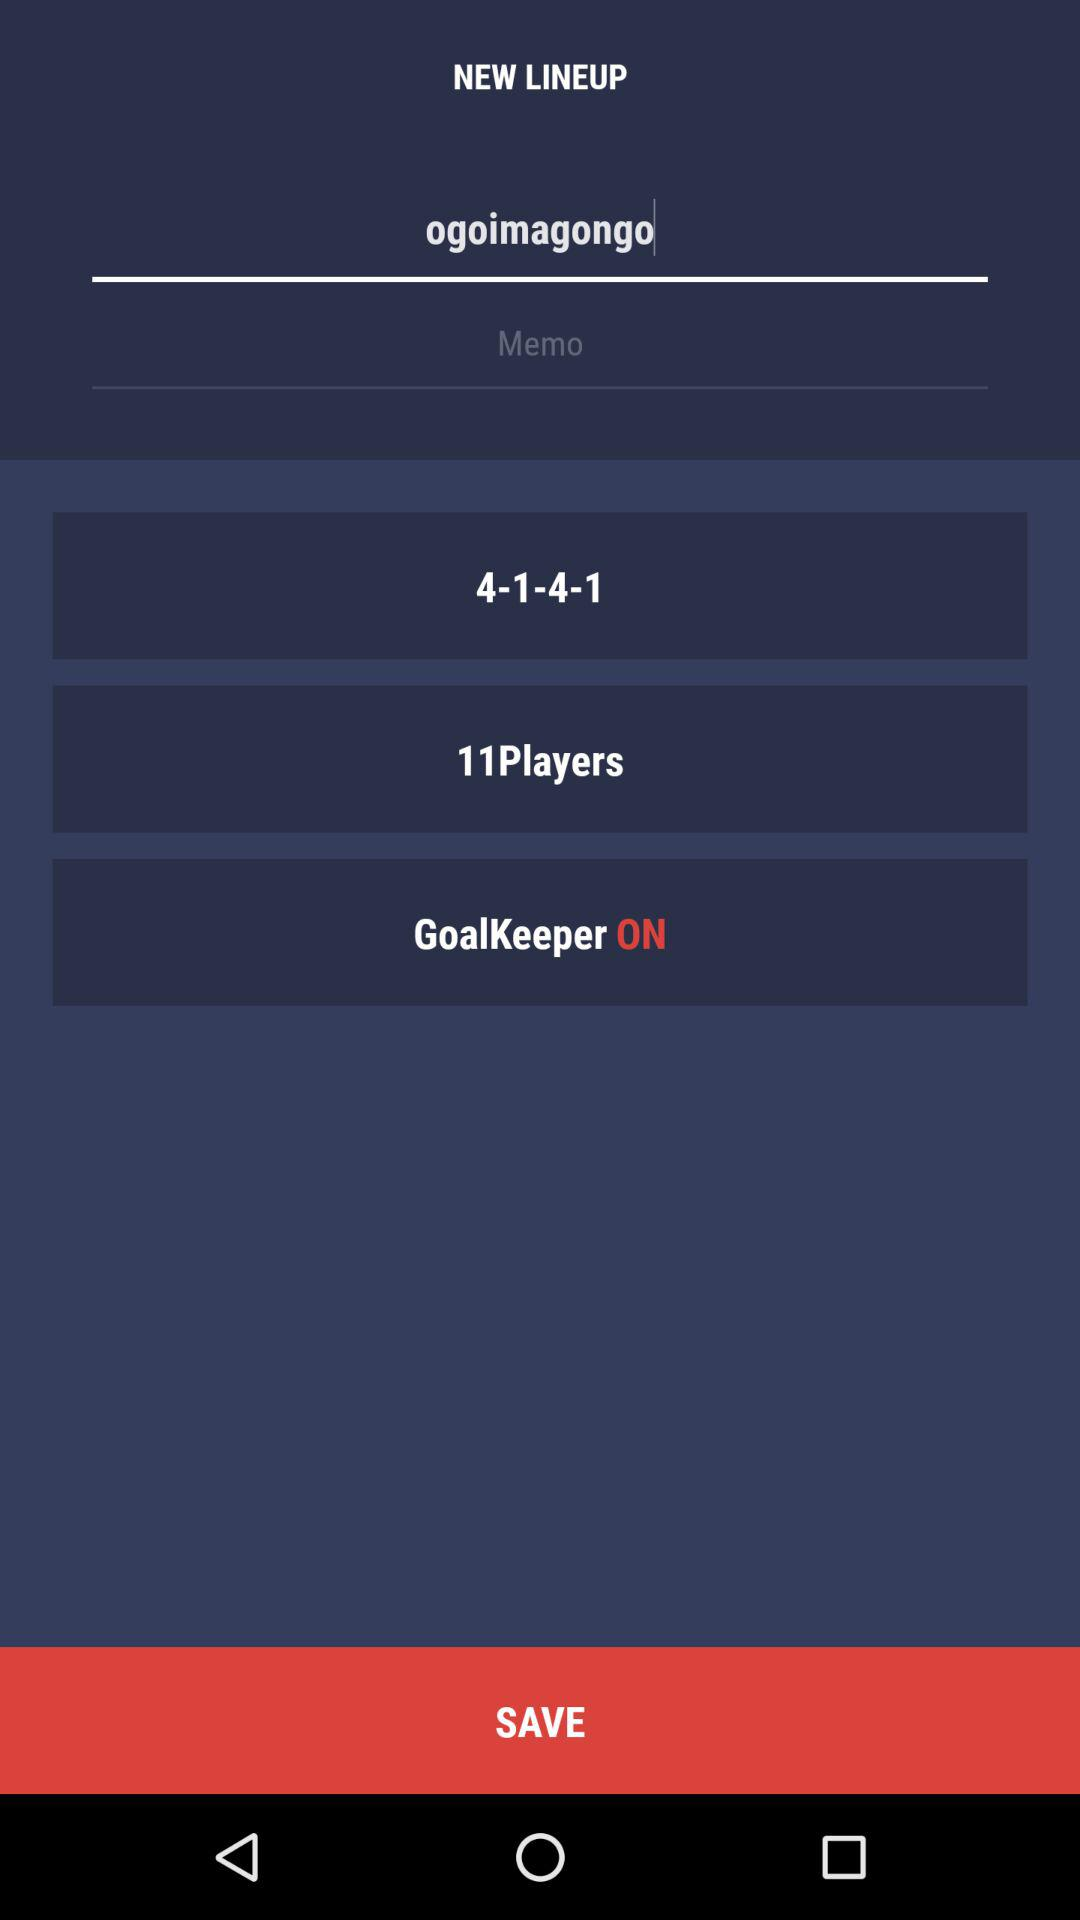What is the status of the goalkeeper? The status is "ON". 